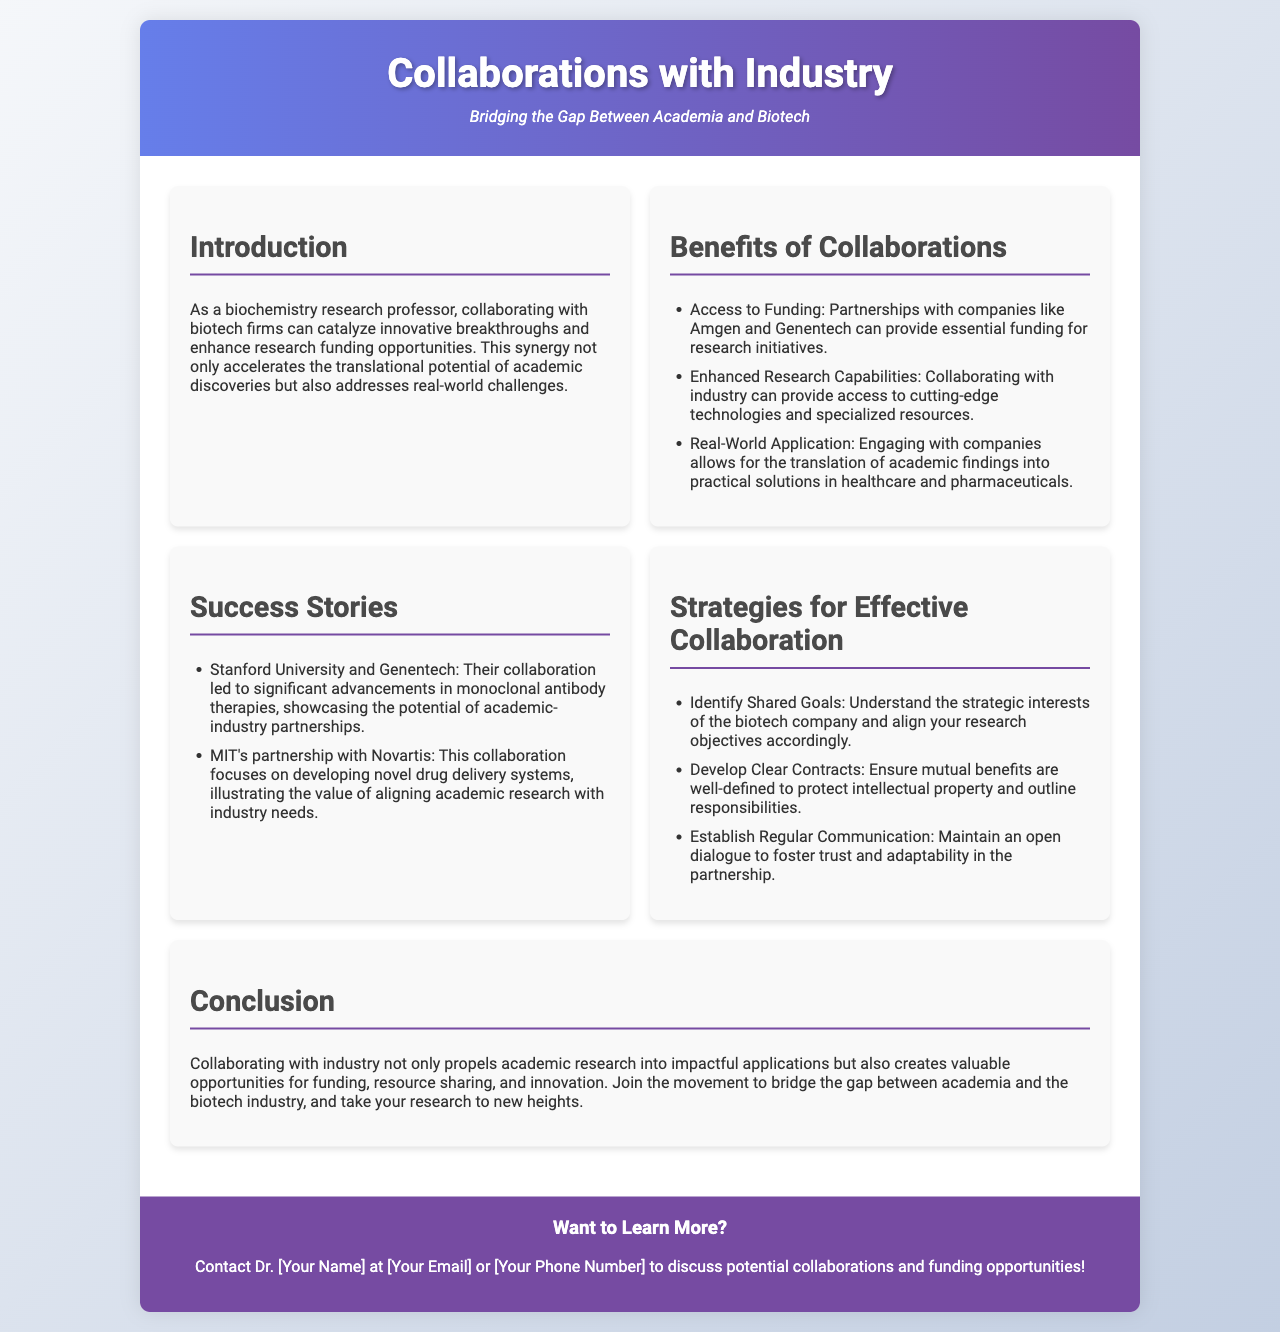what is the title of the brochure? The title is specified in the header section of the document, which states "Collaborations with Industry".
Answer: Collaborations with Industry what is one of the biotech companies mentioned in the brochure? The brochure lists specific companies under the benefits section where funding access is discussed.
Answer: Amgen what is one benefit of collaborating with industry? The brochure outlines several benefits, including enhanced research capabilities and real-world application.
Answer: Access to Funding who collaborated with Genentech according to the success stories? The document names an academic institution that worked with Genentech in the success stories section.
Answer: Stanford University what is a strategy for effective collaboration mentioned in the document? The section on strategies lists several tactics for collaboration, including identifying shared goals.
Answer: Identify Shared Goals how many success stories are highlighted in the brochure? The success stories section lists multiple examples of academic-industry partnerships.
Answer: Two what is the contact method provided for inquiries? The document mentions a general way to reach out for more information regarding collaborations.
Answer: Email or Phone Number what is the goal of the collaborations discussed in the brochure? The introduction and conclusion outline the main aim of these partnerships within the context of biochemistry research.
Answer: Bridging the Gap Between Academia and Biotech 